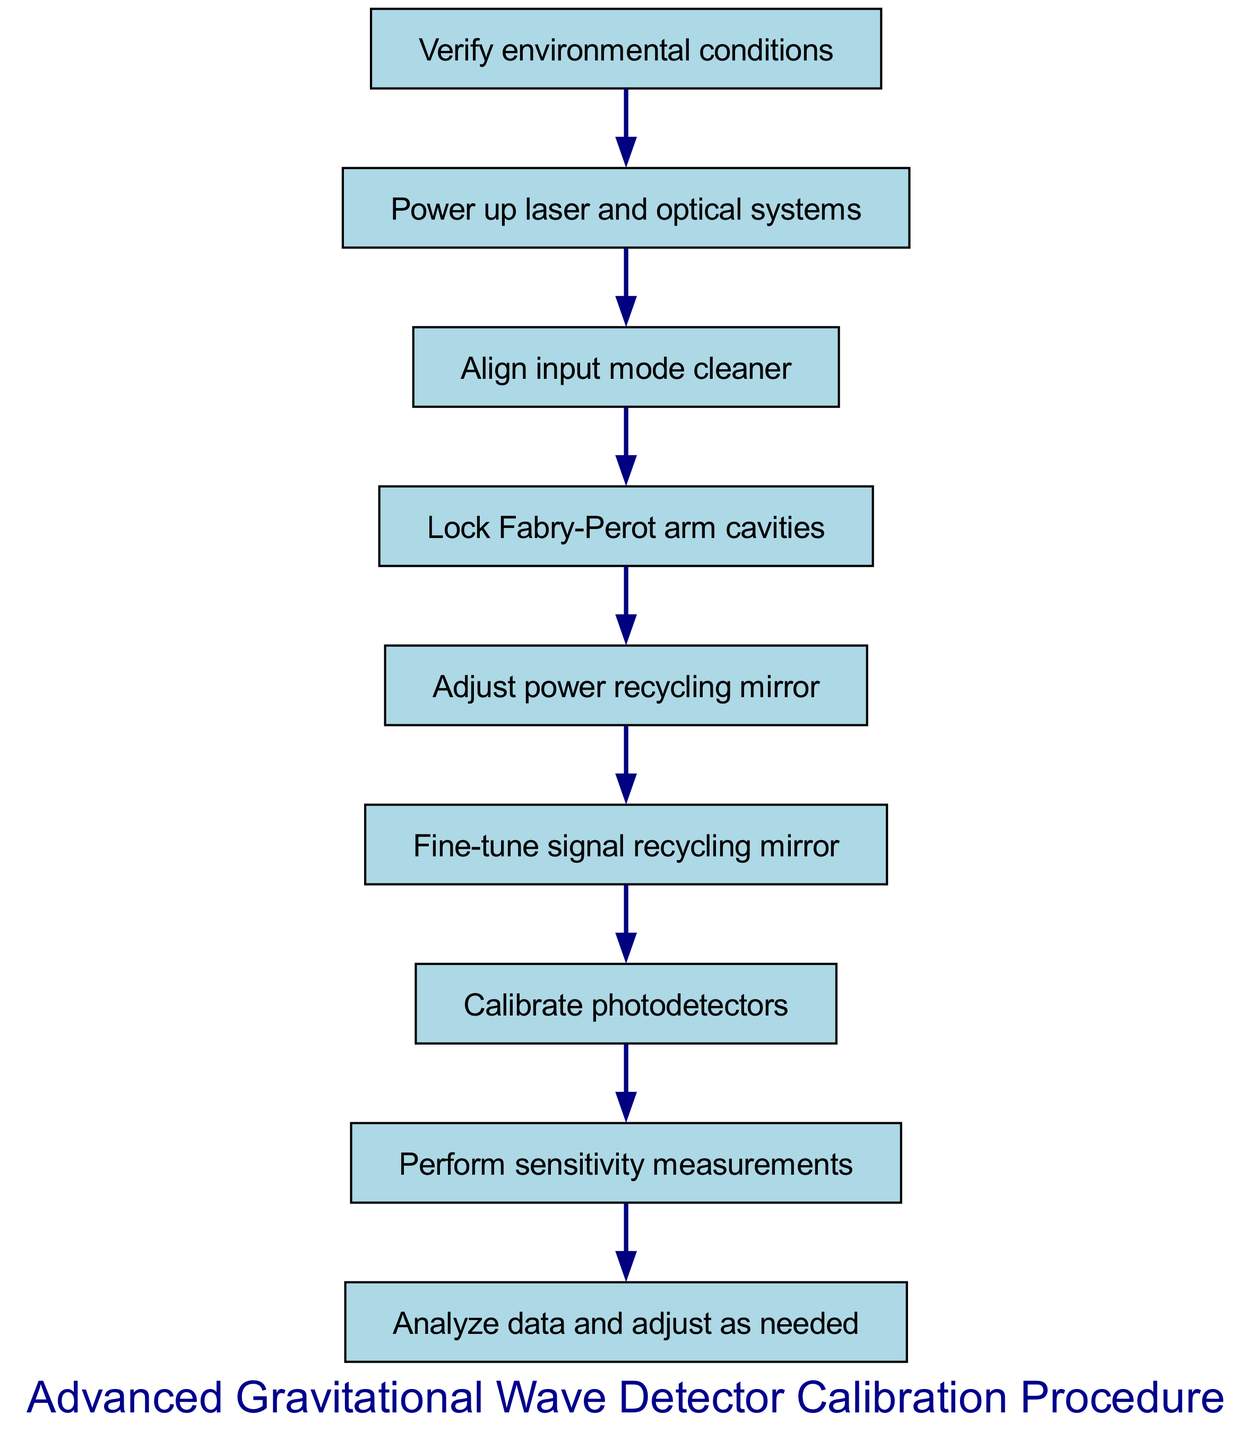What is the first step in the calibration procedure? The first step in the diagram is indicated as "Verify environmental conditions." It is shown at the topmost node of the flowchart.
Answer: Verify environmental conditions How many steps are there in total in the procedure? Counting all the nodes from the diagram, there are a total of nine steps, from verifying conditions to analyzing data.
Answer: Nine What comes after fine-tuning the signal recycling mirror? Following the action of fine-tuning the signal recycling mirror, the next step in the flowchart is to "Calibrate photodetectors," as shown by the directed edge leading to that node.
Answer: Calibrate photodetectors What is the sixth step in the procedure? The sixth step according to the diagram is to "Fine-tune signal recycling mirror," which is reached by following the previous steps sequentially from the start.
Answer: Fine-tune signal recycling mirror Which steps focus on adjusting components? The steps that focus on adjusting components are "Adjust power recycling mirror" and "Fine-tune signal recycling mirror." These steps involve tweaking specific parts of the gravitational wave detection system.
Answer: Adjust power recycling mirror, Fine-tune signal recycling mirror What action is performed just before analyzing data? The step that precedes "Analyze data and adjust as needed" is "Perform sensitivity measurements," as indicated in the flow of the diagram.
Answer: Perform sensitivity measurements What is the last step in this calibration procedure? The diagram indicates that the last step in the calibration procedure is "Analyze data and adjust as needed," indicating the final action to take after performing the sensitivity measurements.
Answer: Analyze data and adjust as needed Which node locks the Fabry-Perot arm cavities? The node that corresponds to the action of locking the Fabry-Perot arm cavities is labeled as "Lock Fabry-Perot arm cavities" in the flowchart, showing its specific placement in the sequence.
Answer: Lock Fabry-Perot arm cavities How do the steps relate to one another in the procedure? The steps in the procedure are connected in a linear sequence where each action leads directly to the next, starting from environmental checks and culminating in data analysis. This indicates a structured approach to the calibration process.
Answer: Linear sequence 